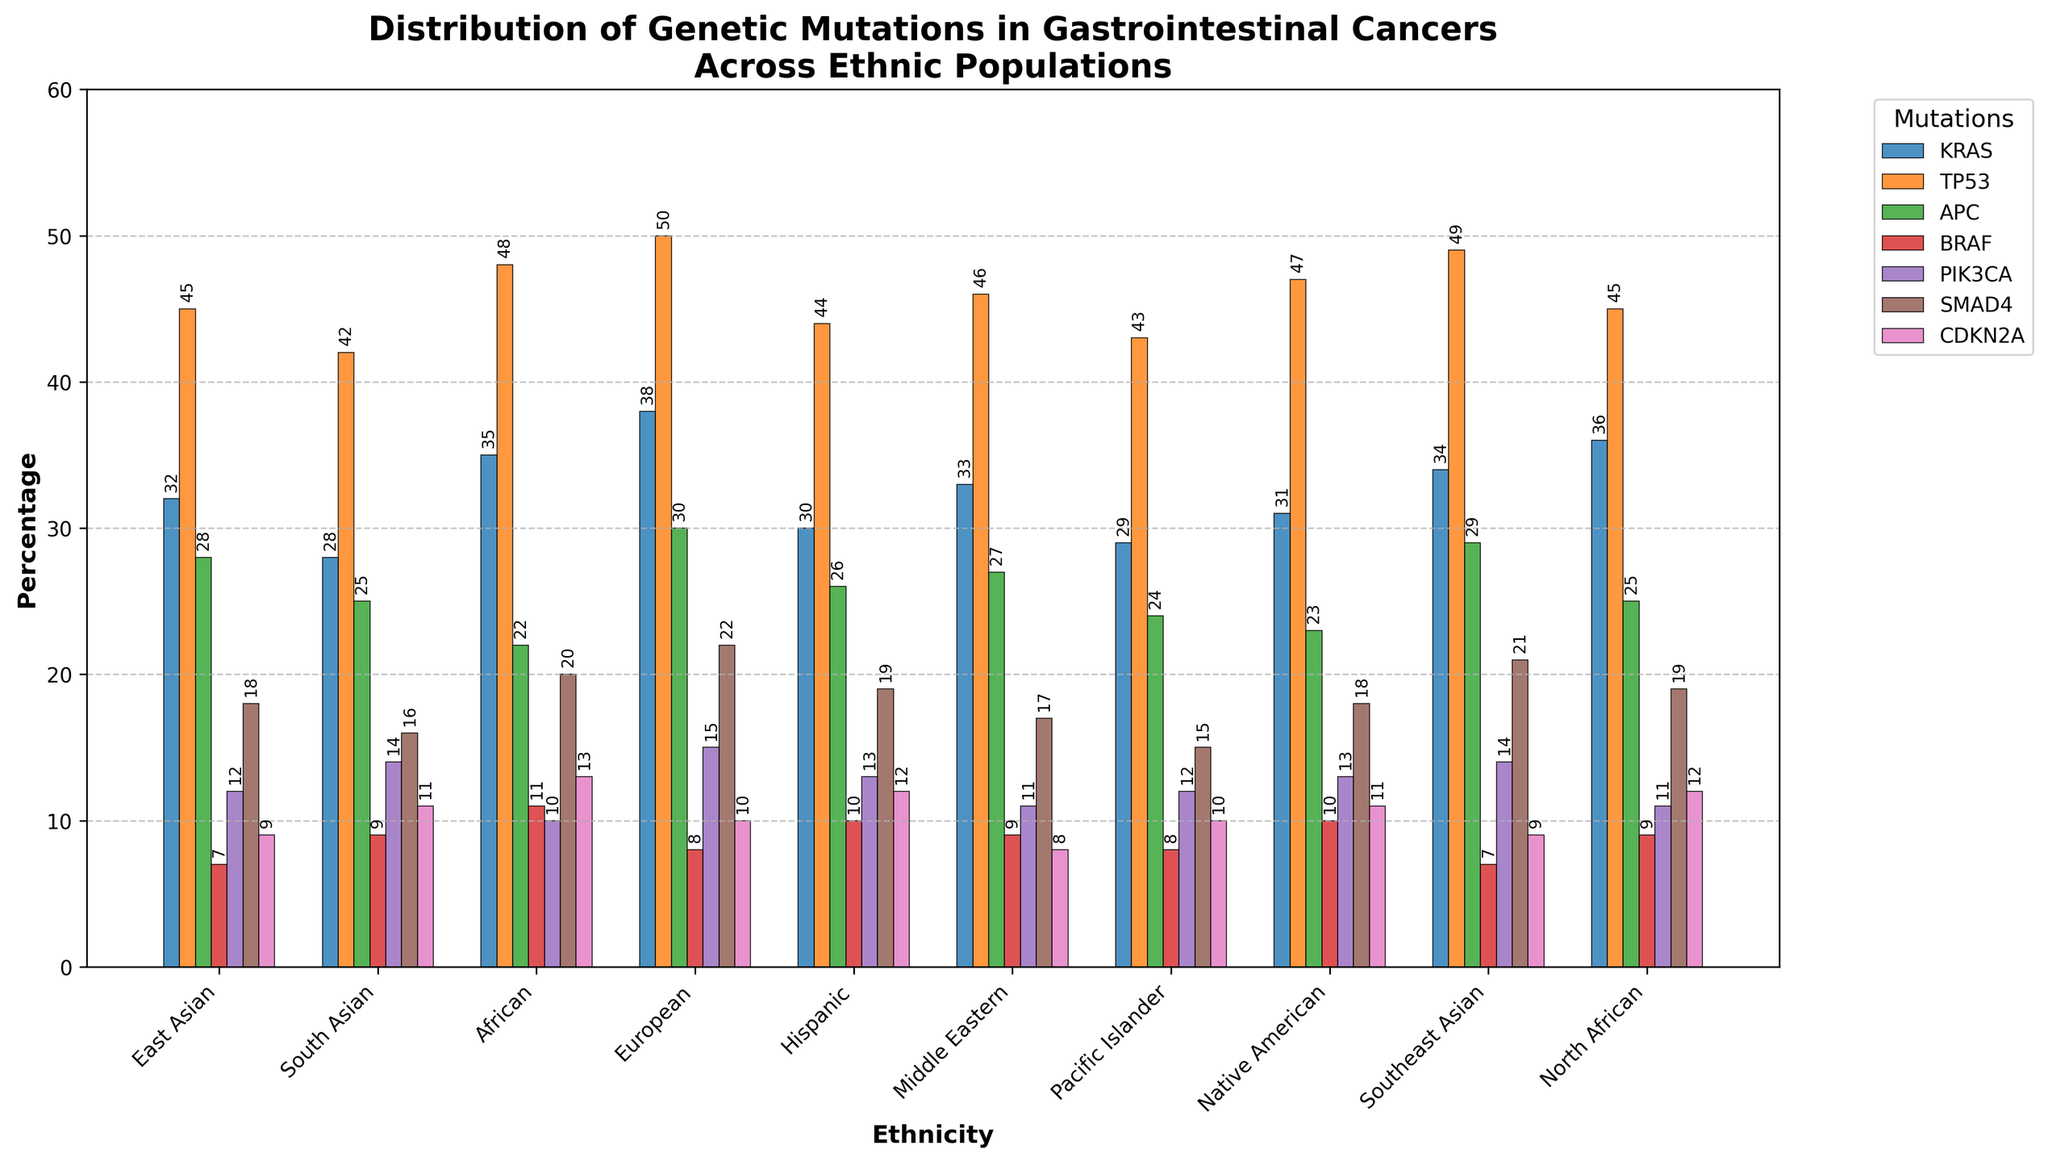What is the average percentage of KRAS mutations across all ethnicities? First, sum all the KRAS percentage values: 32 + 28 + 35 + 38 + 30 + 33 + 29 + 31 + 34 + 36 = 326. Then, divide by the number of ethnicities, which is 10. The average is 326 / 10 = 32.6.
Answer: 32.6 Which ethnicity has the highest percentage of TP53 mutations? Look at the TP53 mutation bars for each ethnicity and find the highest value. The highest TP53 mutation percentage is 50, found in the European population.
Answer: European What is the difference in the percentage of APC mutations between European and South Asian ethnicities? Refer to the heights of the APC bars for European and South Asian populations. European is 30% and South Asian is 25%. The difference is 30 - 25 = 5.
Answer: 5 How many ethnicities have a percentage of PIK3CA mutations above 12%? Count the bars for PIK3CA mutations that exceed 12%. East Asian (12), South Asian (14), Hispanic (13), Middle Eastern (11), Native American (13), Southeast Asian (14), and North African (11) are the values. Therefore, 3 ethnicities exceed 12%: South Asian, Hispanic, and Southeast Asian.
Answer: 3 Which mutation has the most uniform distribution across all ethnicities? Observe all mutation bars across ethnicities and determine which has the least fluctuation. APC has values ranging closely from 22 to 30, suggesting a more uniform distribution compared to others.
Answer: APC What is the total percentage of genetic mutations for the Native American ethnicity? Sum all the percentage values for the Native American row: 31 (KRAS) + 47 (TP53) + 23 (APC) + 10 (BRAF) + 13 (PIK3CA) + 18 (SMAD4) + 11 (CDKN2A) = 153.
Answer: 153 Compare the percentage of SMAD4 mutations in African and North African populations. Which is higher and by how much? Check the SMAD4 mutation bars for African and North African populations. African has 20%, North African has 19%. The African population has a higher percentage by 20 - 19 = 1.
Answer: African by 1 Which ethnicities have exactly 9% BRAF mutations? Identify the ethnic groups where the BRAF mutation bars are at 9%. South Asian, Middle Eastern, and North African populations each have 9% BRAF mutations.
Answer: South Asian, Middle Eastern, North African What is the range of CDKN2A mutation percentages across all ethnicities? Find the minimum and maximum values of the CDKN2A mutation percentages. The values range from 8 (Middle Eastern) to 13 (African). The range is 13 - 8 = 5.
Answer: 5 Which ethnicity has the second lowest percentage of PIK3CA mutations? Find the second smallest bar for PIK3CA mutations across ethnicities. The values are: 12, 14, 10, 15, 13, 11, 12, 13, 14, 11. The second lowest is 11, present in Middle Eastern and North African populations.
Answer: Middle Eastern, North African 